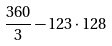<formula> <loc_0><loc_0><loc_500><loc_500>\frac { 3 6 0 } { 3 } - 1 2 3 \cdot 1 2 8</formula> 